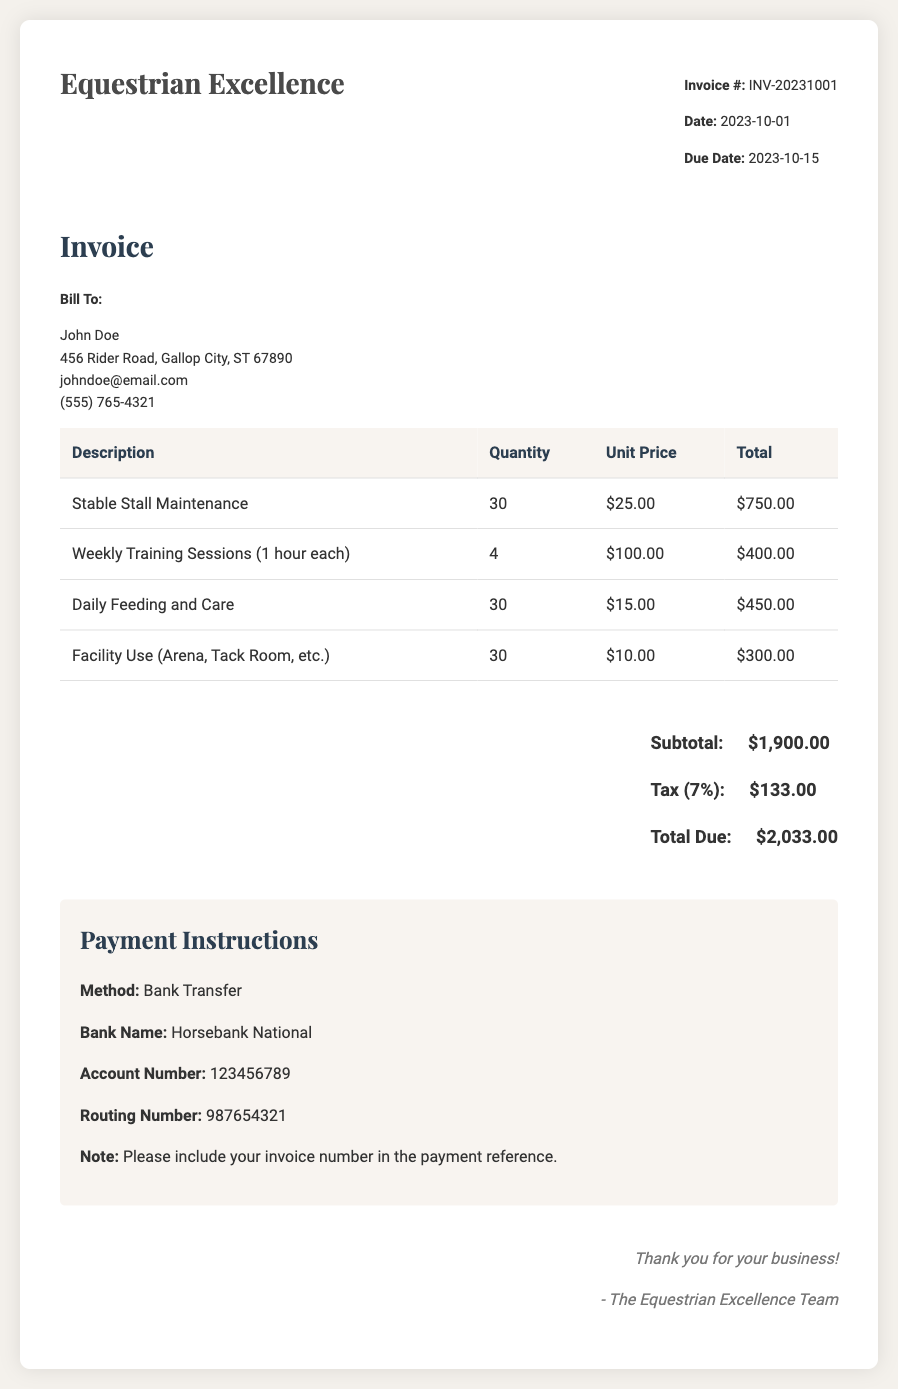What is the invoice number? The invoice number is specified in the invoice header as INV-20231001.
Answer: INV-20231001 What is the date of the invoice? The date of the invoice is provided in the invoice header section as 2023-10-01.
Answer: 2023-10-01 How much is charged for daily feeding and care? The unit price for daily feeding and care is mentioned in the table as $15.00.
Answer: $15.00 How many weekly training sessions are included? The quantity of weekly training sessions is noted in the table as 4.
Answer: 4 What is the total amount due? The total due amount is calculated and presented in the summary section as $2,033.00.
Answer: $2,033.00 What is the subtotal before tax? The subtotal is found in the summary section before any tax is applied, which is $1,900.00.
Answer: $1,900.00 Which payment method is specified? The payment method is indicated in the payment instructions as Bank Transfer.
Answer: Bank Transfer What is the tax percentage applied? The tax percentage is stated in the summary section as 7%.
Answer: 7% What is included in the services provided? The services listed include stable stall maintenance, training sessions, daily feeding and care, and facility use.
Answer: Stable stall maintenance, training sessions, daily feeding and care, facility use 